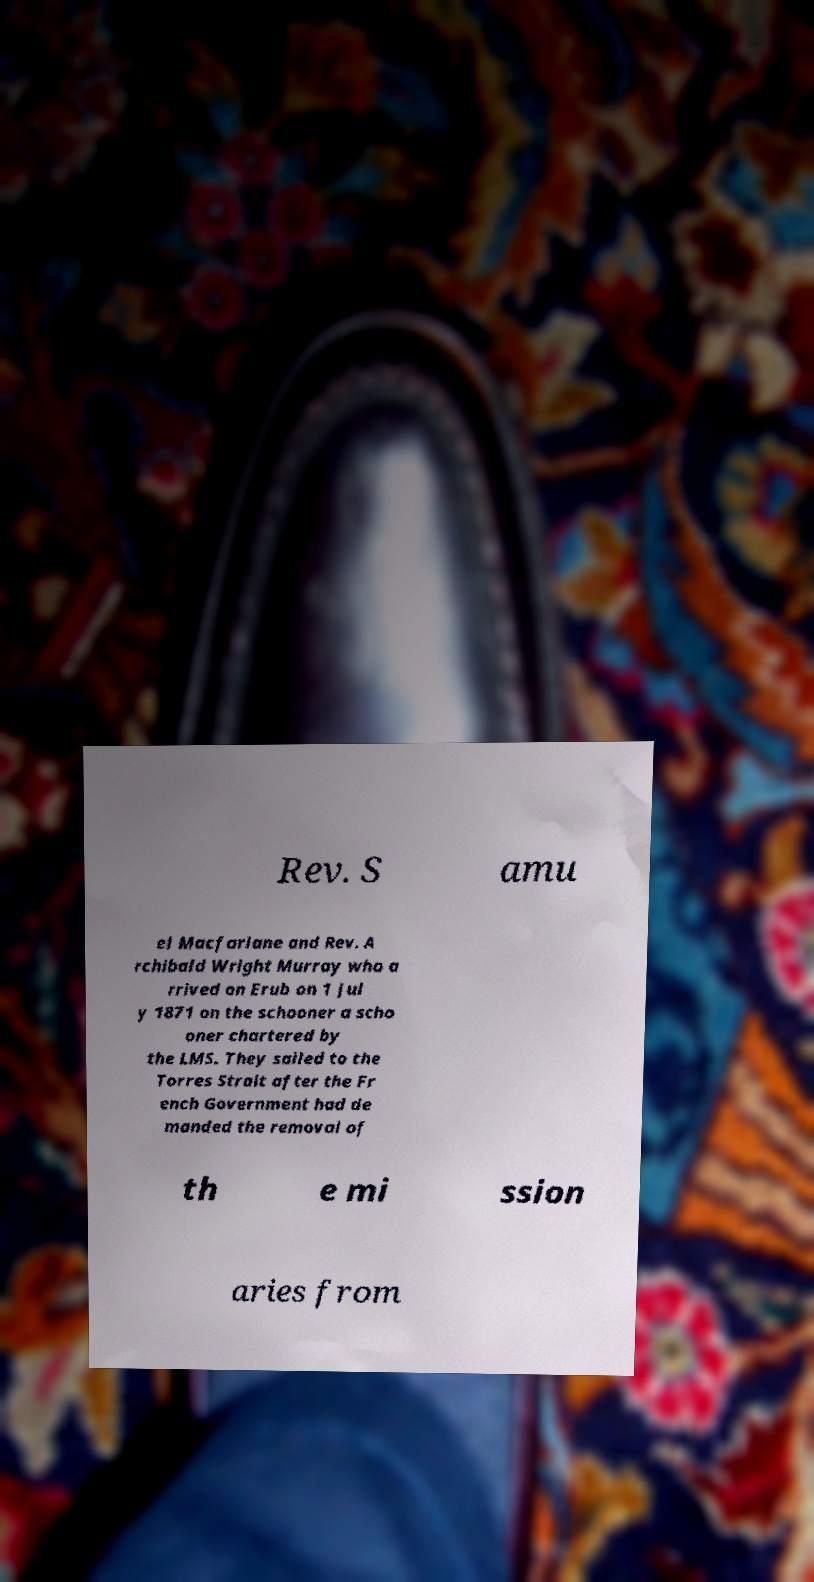I need the written content from this picture converted into text. Can you do that? Rev. S amu el Macfarlane and Rev. A rchibald Wright Murray who a rrived on Erub on 1 Jul y 1871 on the schooner a scho oner chartered by the LMS. They sailed to the Torres Strait after the Fr ench Government had de manded the removal of th e mi ssion aries from 